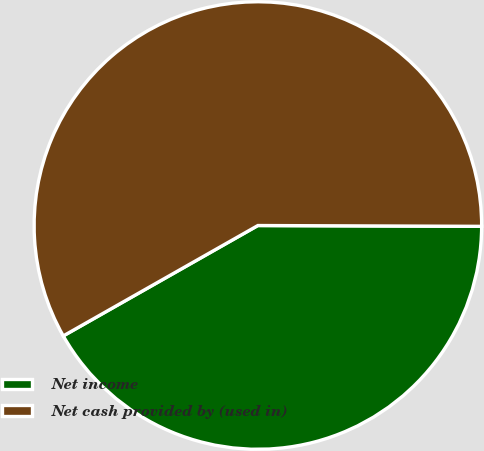Convert chart. <chart><loc_0><loc_0><loc_500><loc_500><pie_chart><fcel>Net income<fcel>Net cash provided by (used in)<nl><fcel>41.73%<fcel>58.27%<nl></chart> 